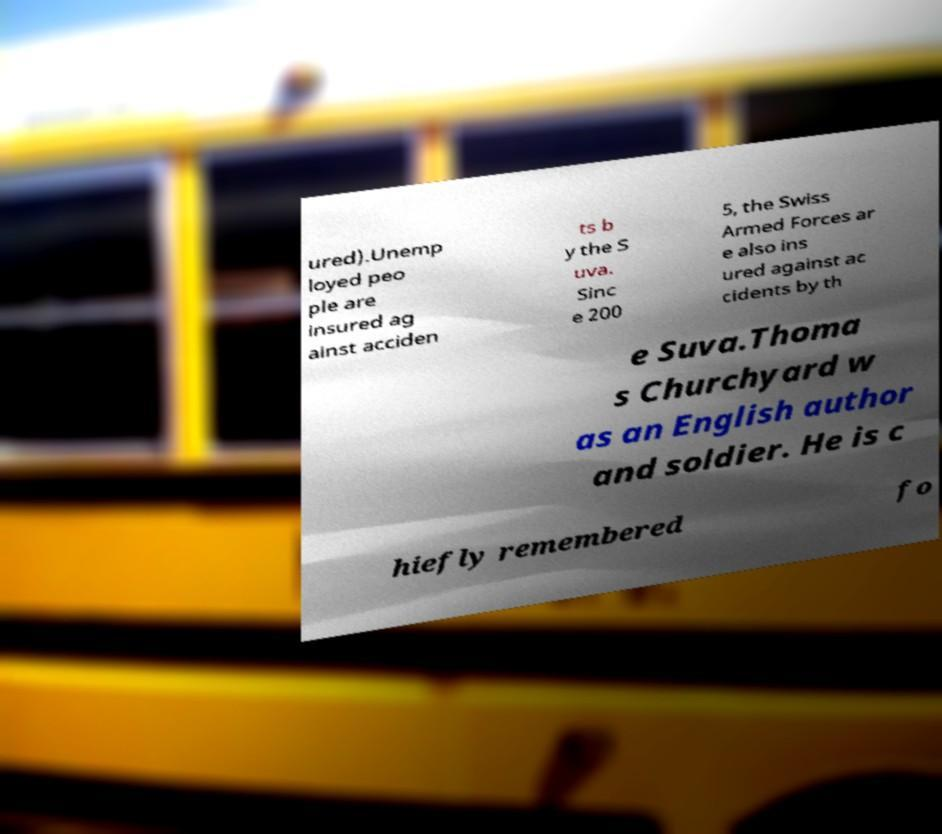I need the written content from this picture converted into text. Can you do that? ured).Unemp loyed peo ple are insured ag ainst acciden ts b y the S uva. Sinc e 200 5, the Swiss Armed Forces ar e also ins ured against ac cidents by th e Suva.Thoma s Churchyard w as an English author and soldier. He is c hiefly remembered fo 